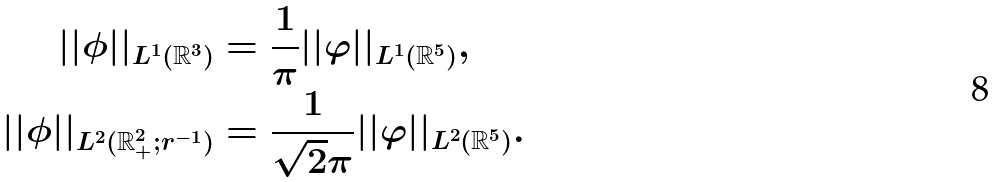<formula> <loc_0><loc_0><loc_500><loc_500>| | \phi | | _ { L ^ { 1 } ( \mathbb { R } ^ { 3 } ) } & = \frac { 1 } { \pi } | | \varphi | | _ { L ^ { 1 } ( \mathbb { R } ^ { 5 } ) } , \\ | | \phi | | _ { L ^ { 2 } ( \mathbb { R } ^ { 2 } _ { + } ; r ^ { - 1 } ) } & = \frac { 1 } { \sqrt { 2 } \pi } | | \varphi | | _ { L ^ { 2 } ( \mathbb { R } ^ { 5 } ) } .</formula> 